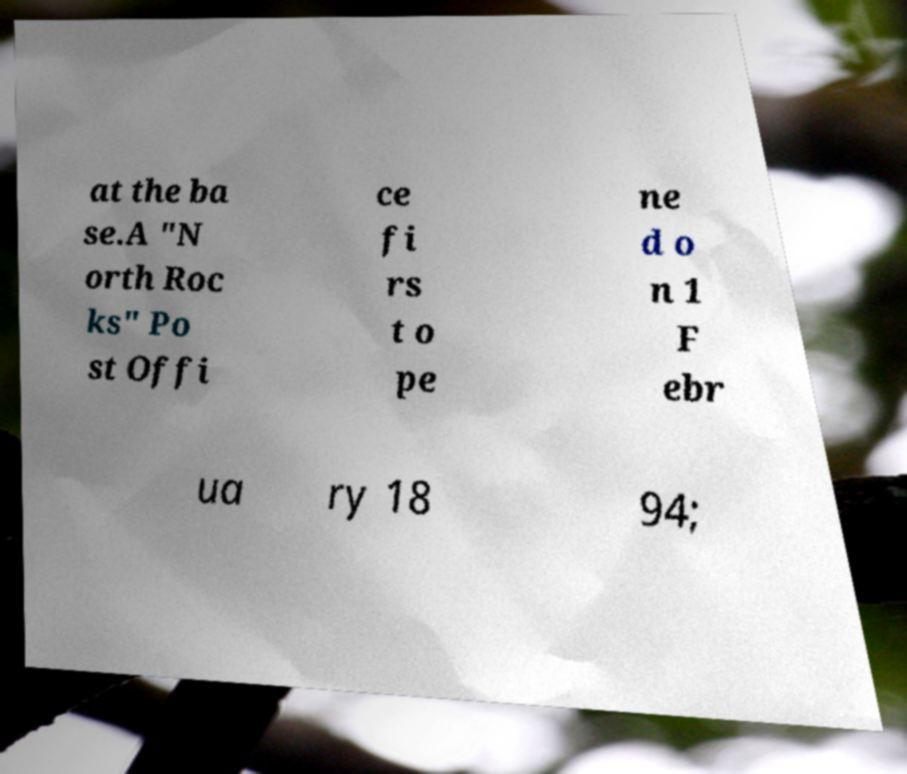Can you read and provide the text displayed in the image?This photo seems to have some interesting text. Can you extract and type it out for me? at the ba se.A "N orth Roc ks" Po st Offi ce fi rs t o pe ne d o n 1 F ebr ua ry 18 94; 